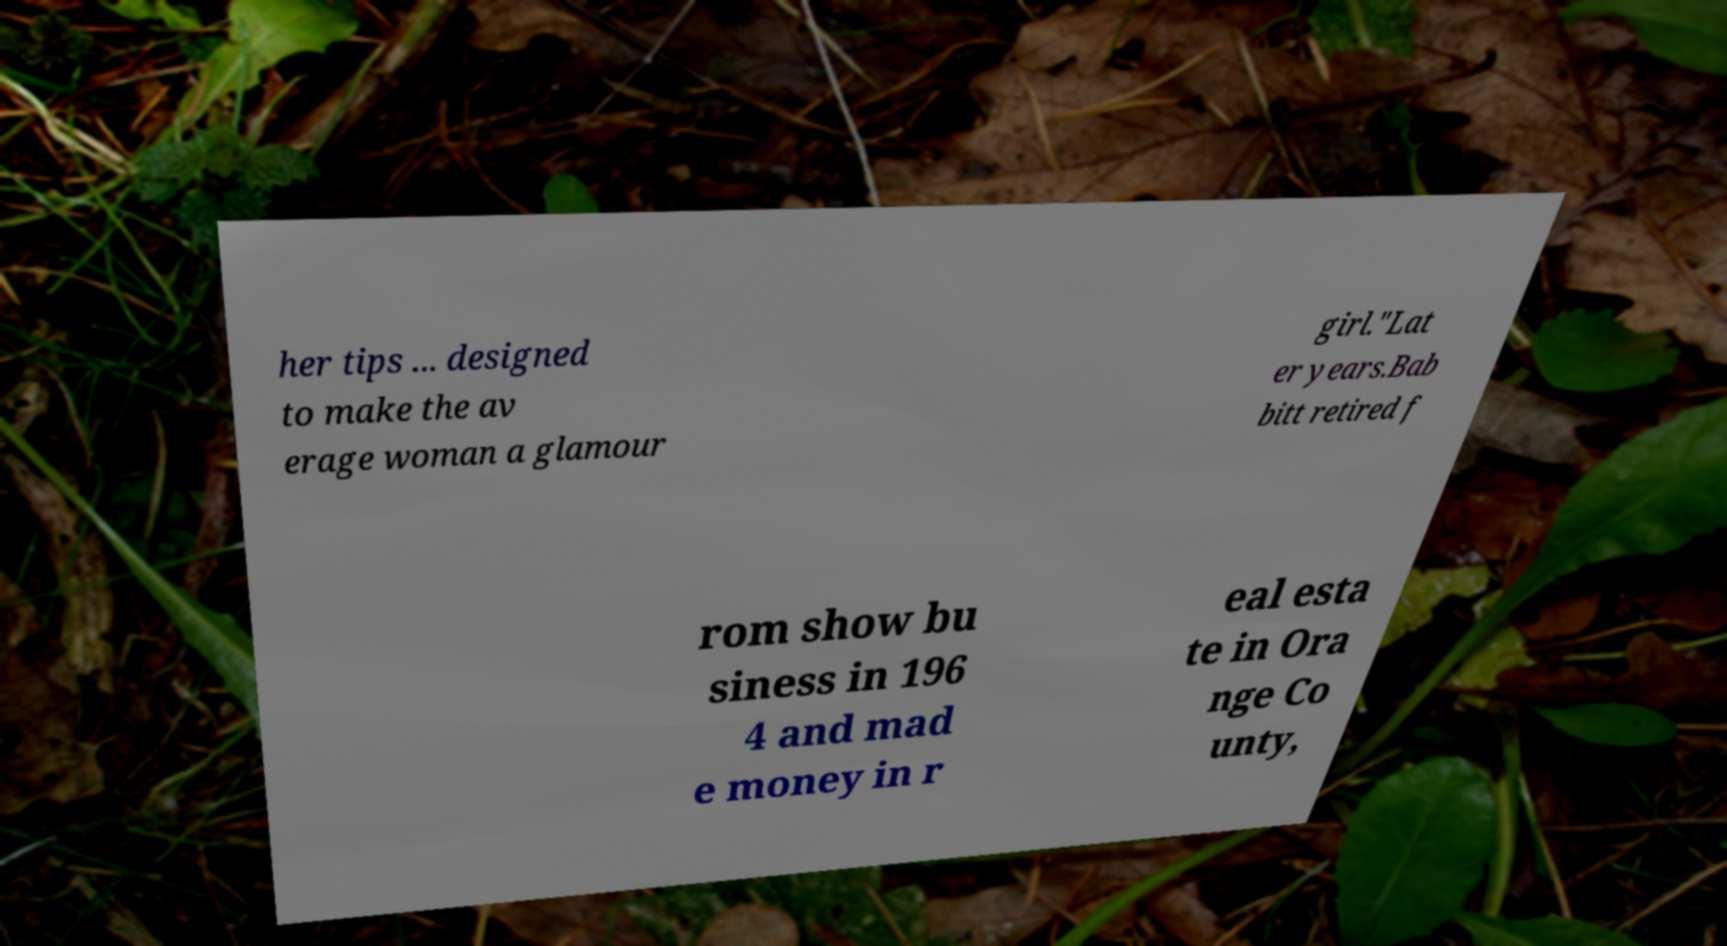Please read and relay the text visible in this image. What does it say? her tips ... designed to make the av erage woman a glamour girl."Lat er years.Bab bitt retired f rom show bu siness in 196 4 and mad e money in r eal esta te in Ora nge Co unty, 